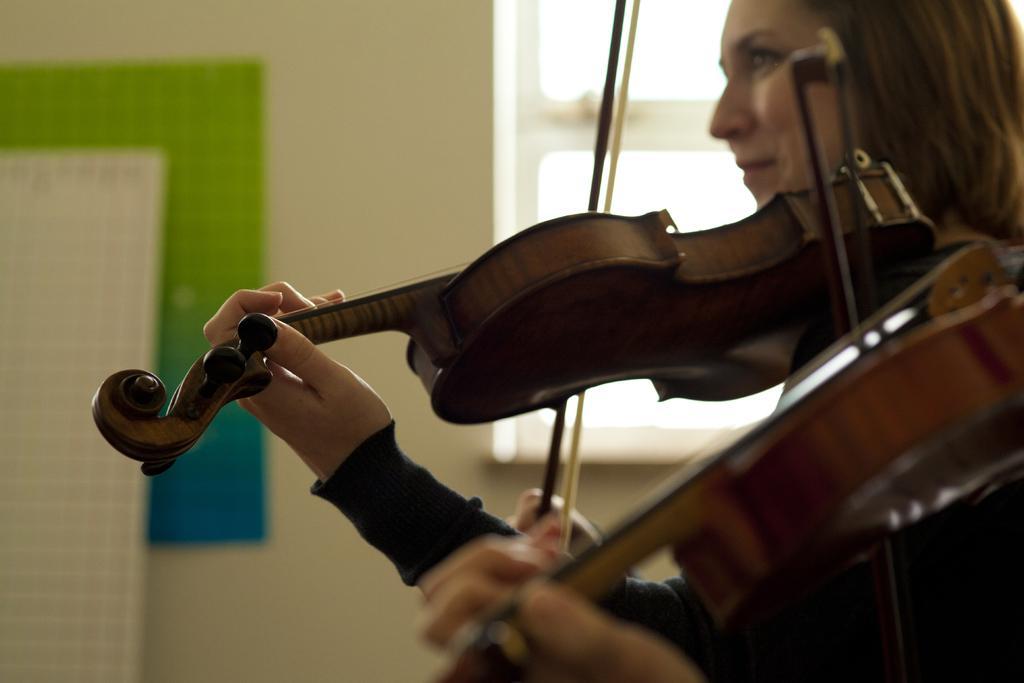In one or two sentences, can you explain what this image depicts? In this image we can see a woman, and she is smiling, playing the violin, and here is the wall, and here is the window. 